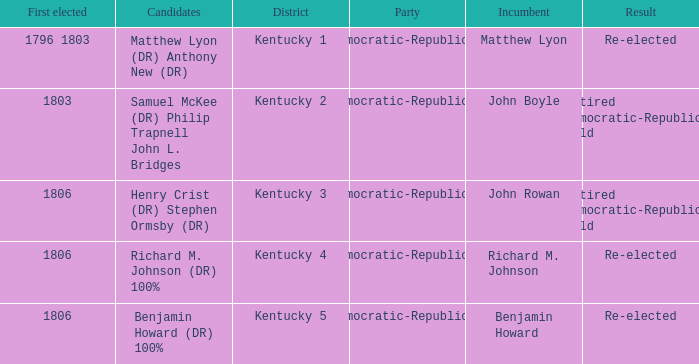Name the number of party for kentucky 1 1.0. 